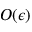<formula> <loc_0><loc_0><loc_500><loc_500>O ( \epsilon )</formula> 